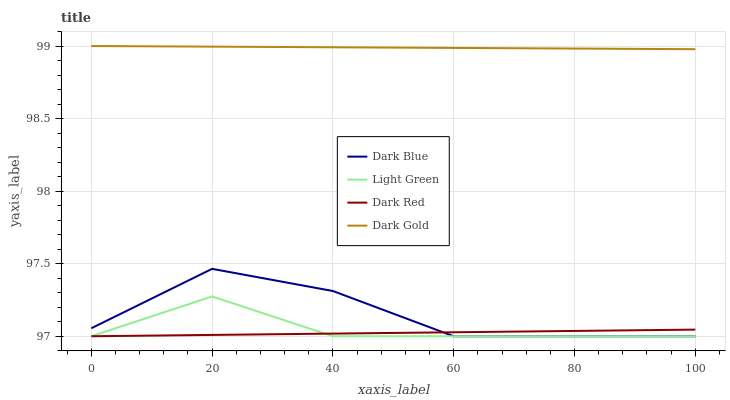Does Light Green have the minimum area under the curve?
Answer yes or no. No. Does Light Green have the maximum area under the curve?
Answer yes or no. No. Is Light Green the smoothest?
Answer yes or no. No. Is Light Green the roughest?
Answer yes or no. No. Does Dark Gold have the lowest value?
Answer yes or no. No. Does Light Green have the highest value?
Answer yes or no. No. Is Dark Red less than Dark Gold?
Answer yes or no. Yes. Is Dark Gold greater than Light Green?
Answer yes or no. Yes. Does Dark Red intersect Dark Gold?
Answer yes or no. No. 